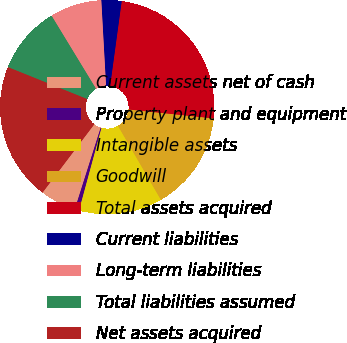<chart> <loc_0><loc_0><loc_500><loc_500><pie_chart><fcel>Current assets net of cash<fcel>Property plant and equipment<fcel>Intangible assets<fcel>Goodwill<fcel>Total assets acquired<fcel>Current liabilities<fcel>Long-term liabilities<fcel>Total liabilities assumed<fcel>Net assets acquired<nl><fcel>5.43%<fcel>0.66%<fcel>12.59%<fcel>14.97%<fcel>24.51%<fcel>3.04%<fcel>7.82%<fcel>10.2%<fcel>20.78%<nl></chart> 